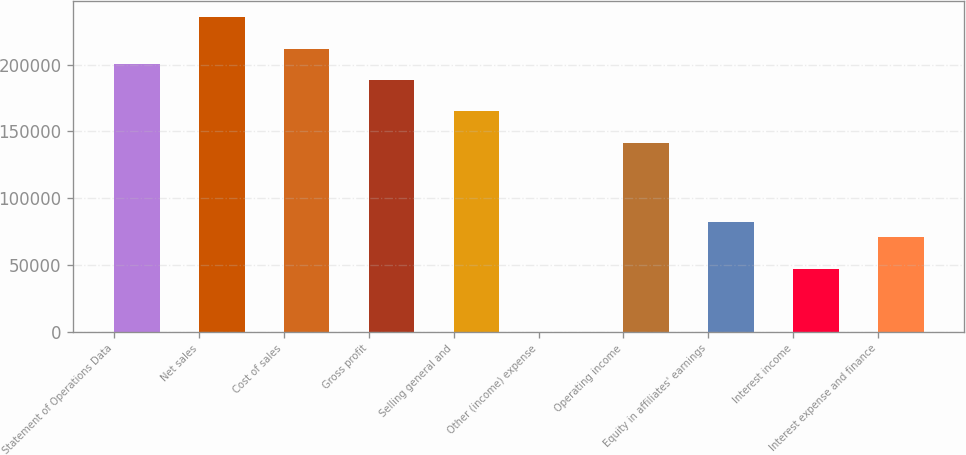Convert chart to OTSL. <chart><loc_0><loc_0><loc_500><loc_500><bar_chart><fcel>Statement of Operations Data<fcel>Net sales<fcel>Cost of sales<fcel>Gross profit<fcel>Selling general and<fcel>Other (income) expense<fcel>Operating income<fcel>Equity in affiliates' earnings<fcel>Interest income<fcel>Interest expense and finance<nl><fcel>200328<fcel>235680<fcel>212112<fcel>188544<fcel>164976<fcel>0.1<fcel>141408<fcel>82488<fcel>47136.1<fcel>70704<nl></chart> 